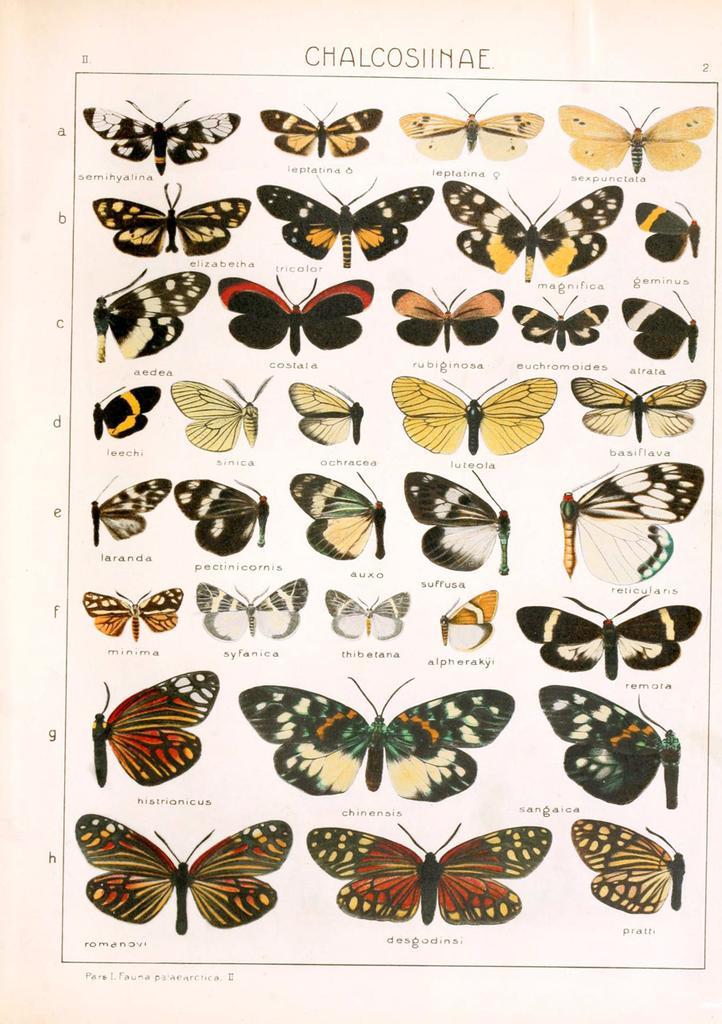Can you describe this image briefly? In this image we can see a poster with some butterflies and text on it. 